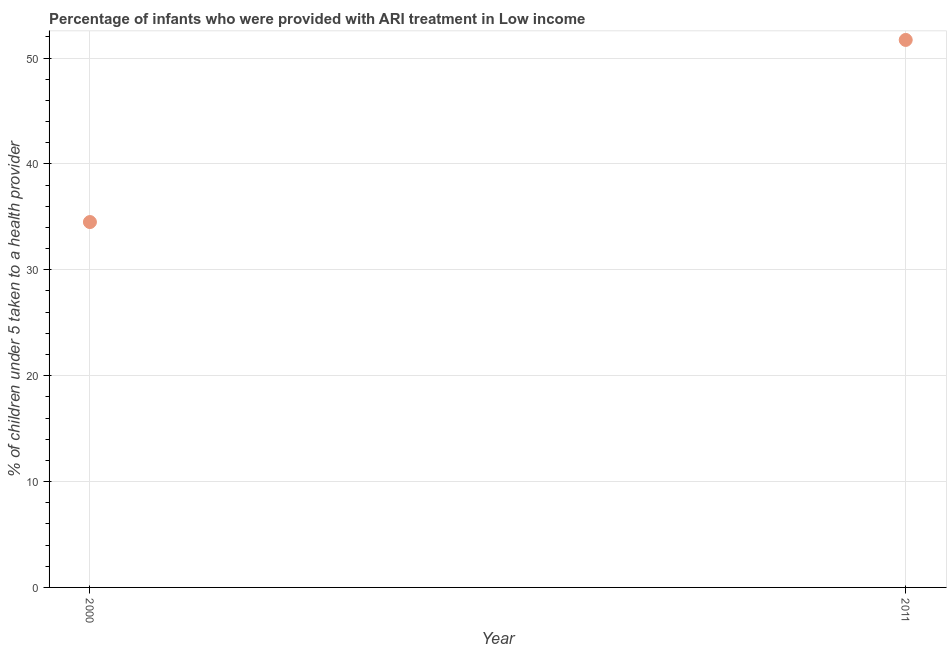What is the percentage of children who were provided with ari treatment in 2000?
Ensure brevity in your answer.  34.51. Across all years, what is the maximum percentage of children who were provided with ari treatment?
Your answer should be very brief. 51.72. Across all years, what is the minimum percentage of children who were provided with ari treatment?
Your answer should be very brief. 34.51. In which year was the percentage of children who were provided with ari treatment maximum?
Provide a succinct answer. 2011. What is the sum of the percentage of children who were provided with ari treatment?
Keep it short and to the point. 86.23. What is the difference between the percentage of children who were provided with ari treatment in 2000 and 2011?
Your response must be concise. -17.2. What is the average percentage of children who were provided with ari treatment per year?
Provide a short and direct response. 43.11. What is the median percentage of children who were provided with ari treatment?
Give a very brief answer. 43.11. In how many years, is the percentage of children who were provided with ari treatment greater than 46 %?
Offer a very short reply. 1. What is the ratio of the percentage of children who were provided with ari treatment in 2000 to that in 2011?
Offer a very short reply. 0.67. How many dotlines are there?
Provide a succinct answer. 1. What is the difference between two consecutive major ticks on the Y-axis?
Ensure brevity in your answer.  10. Does the graph contain grids?
Your response must be concise. Yes. What is the title of the graph?
Keep it short and to the point. Percentage of infants who were provided with ARI treatment in Low income. What is the label or title of the X-axis?
Ensure brevity in your answer.  Year. What is the label or title of the Y-axis?
Provide a succinct answer. % of children under 5 taken to a health provider. What is the % of children under 5 taken to a health provider in 2000?
Offer a very short reply. 34.51. What is the % of children under 5 taken to a health provider in 2011?
Make the answer very short. 51.72. What is the difference between the % of children under 5 taken to a health provider in 2000 and 2011?
Offer a very short reply. -17.2. What is the ratio of the % of children under 5 taken to a health provider in 2000 to that in 2011?
Your answer should be compact. 0.67. 